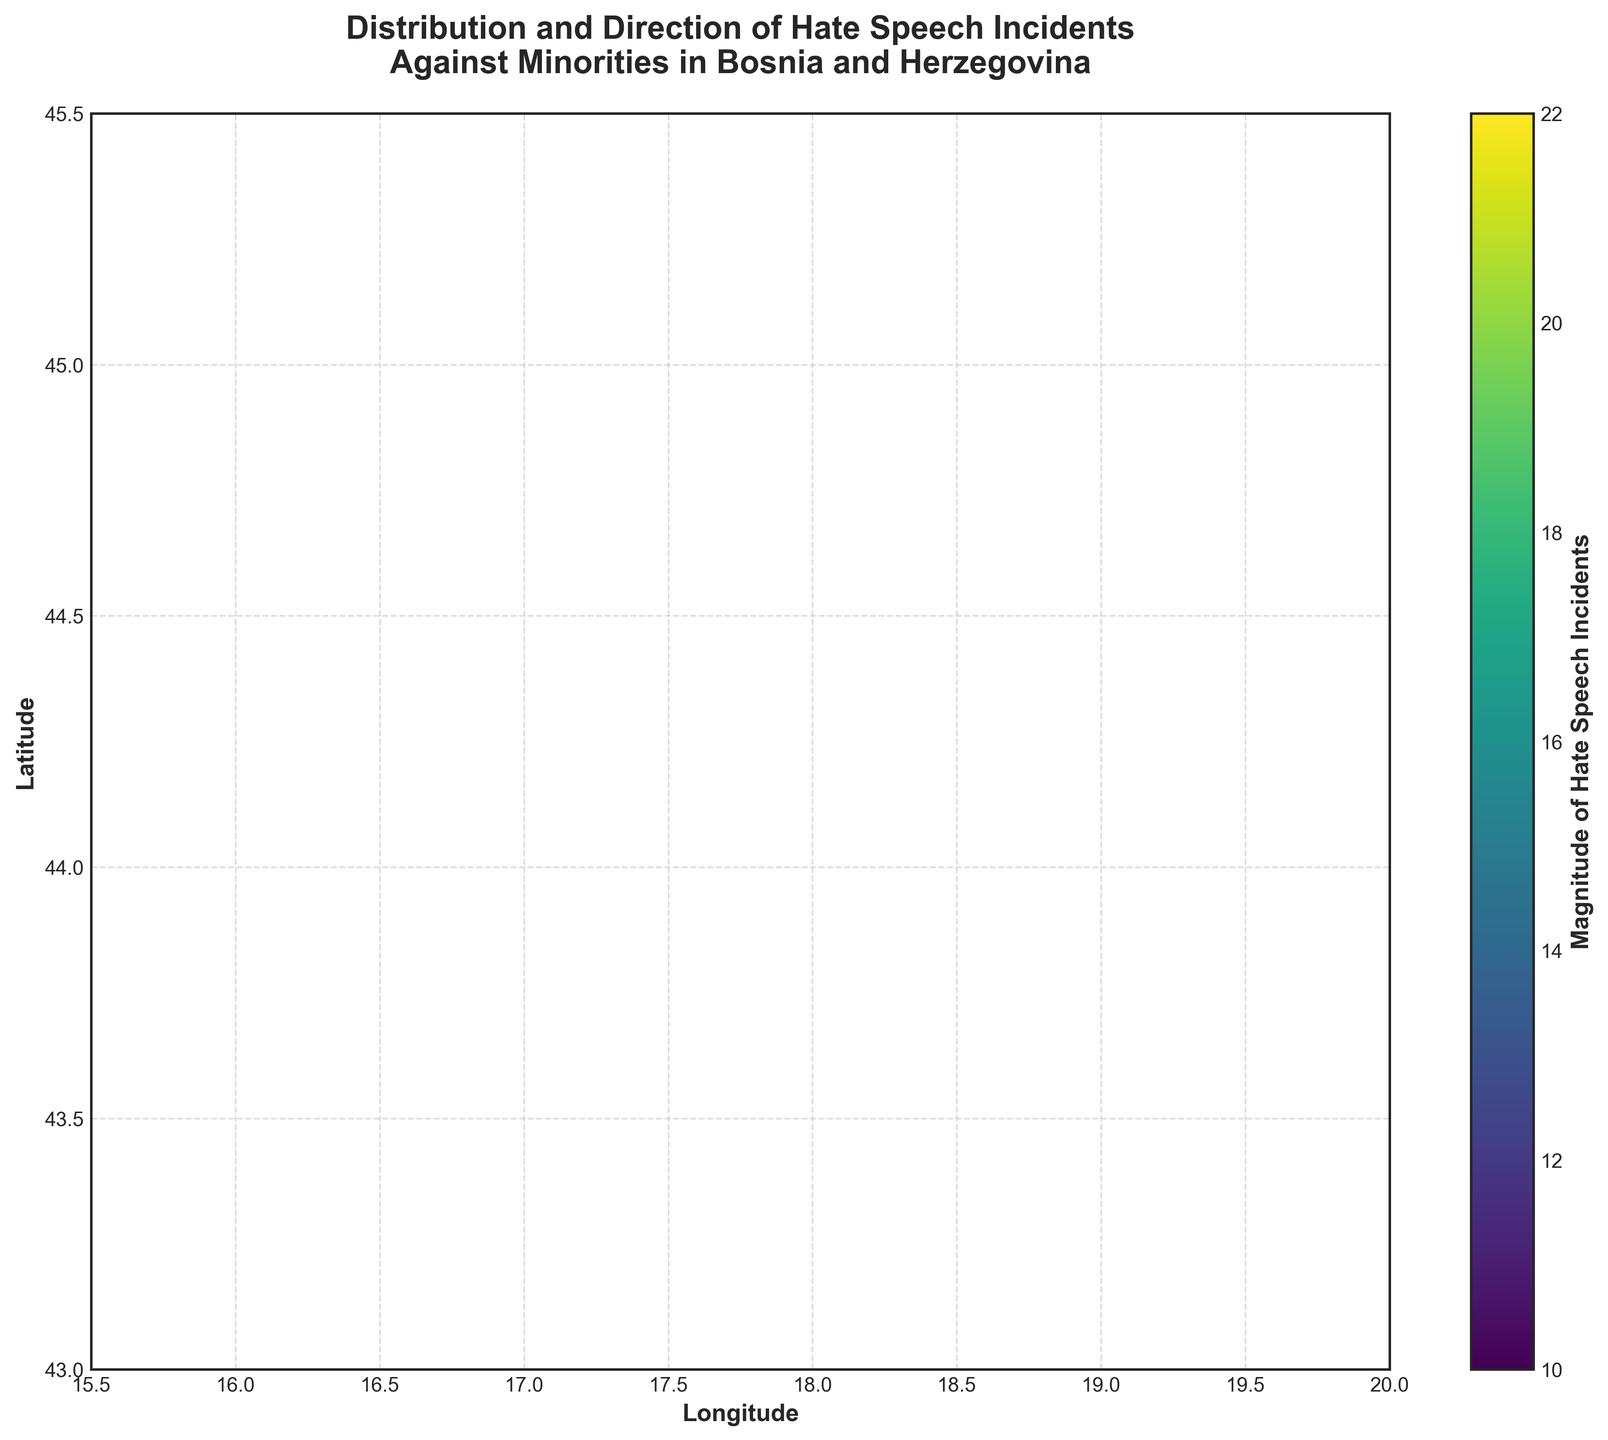What is the title of the plot? The title of the plot is written at the top of the figure and it reads: "Distribution and Direction of Hate Speech Incidents Against Minorities in Bosnia and Herzegovina".
Answer: Distribution and Direction of Hate Speech Incidents Against Minorities in Bosnia and Herzegovina How many regions are included in the figure? There are labels for each region on the plot, totaling to 10 different regions being displayed. The regions are Banja Luka, Sarajevo, Tuzla, Mostar, Prijedor, Zenica, Gorazde, Bihac, Bijeljina, Foca.
Answer: 10 Which region has the highest magnitude of hate speech incidents? By looking at the colorbar and the colors assigned to each arrow, Sarajevo, represented in a color closer to the top of the scale (22), has the highest magnitude of hate speech incidents.
Answer: Sarajevo What is the general direction of hate speech incidents in Zenica? Examining the arrow for Zenica, we see that it is pointing left (negative x direction) and slightly downwards (negative y direction).
Answer: Left and slightly downwards Which regions show a movement pointed northwards? By identifying arrows pointing upwards, Banja Luka, Tuzla, Prijedor, and Foca have components in the positive y direction, indicating northward movement.
Answer: Banja Luka, Tuzla, Prijedor, Foca Compare the direction of hate speech incidents in Gorazde and Sarajevo. The arrow direction in Gorazde points slightly to the right (positive x) and slightly up (positive y), while in Sarajevo, the arrow points slightly right but predominantly downwards (negative y). Therefore, Gorazde’s direction is more towards the northeast whereas Sarajevo’s is more towards the southeast.
Answer: Gorazde: northeast, Sarajevo: southeast What is the average magnitude of hate speech incidents across all regions? The magnitudes given are: 15, 22, 18, 12, 20, 14, 10, 16, 13, 19. Summing these up gives 159, and dividing by the number of regions (10) results in an average magnitude of 15.9.
Answer: 15.9 Which region shows the strongest westward movement of hate speech incidents? The largest negative x component in movement can be found in Banja Luka and Zenica, both showing -0.3. Looking at the data, Banja Luka has a higher impact magnitude (15 vs. 14). Therefore, Banja Luka shows the strongest westward movement.
Answer: Banja Luka What are the extremes in hate speech magnitude, and which regions do they correspond to? From the color bar and corresponding magnitudes, the minimum magnitude is 10 in Gorazde, and the maximum magnitude is 22 in Sarajevo.
Answer: Minimum: Gorazde, Maximum: Sarajevo Which regions indicate both positive and negative components in their hate speech incidents movement? By inspecting the arrows’ directions, both Prijedor and Bijeljina indicate mixed components where Prijedor shows (0.1, 0.5) and Bijeljina shows (0.3, -0.2), meaning they have positive and negative values along different axes.
Answer: Prijedor, Bijeljina 